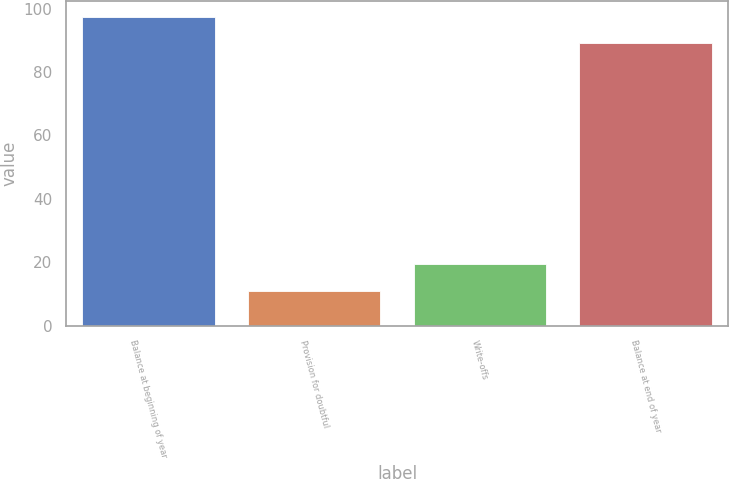<chart> <loc_0><loc_0><loc_500><loc_500><bar_chart><fcel>Balance at beginning of year<fcel>Provision for doubtful<fcel>Write-offs<fcel>Balance at end of year<nl><fcel>97.4<fcel>11<fcel>19.4<fcel>89<nl></chart> 